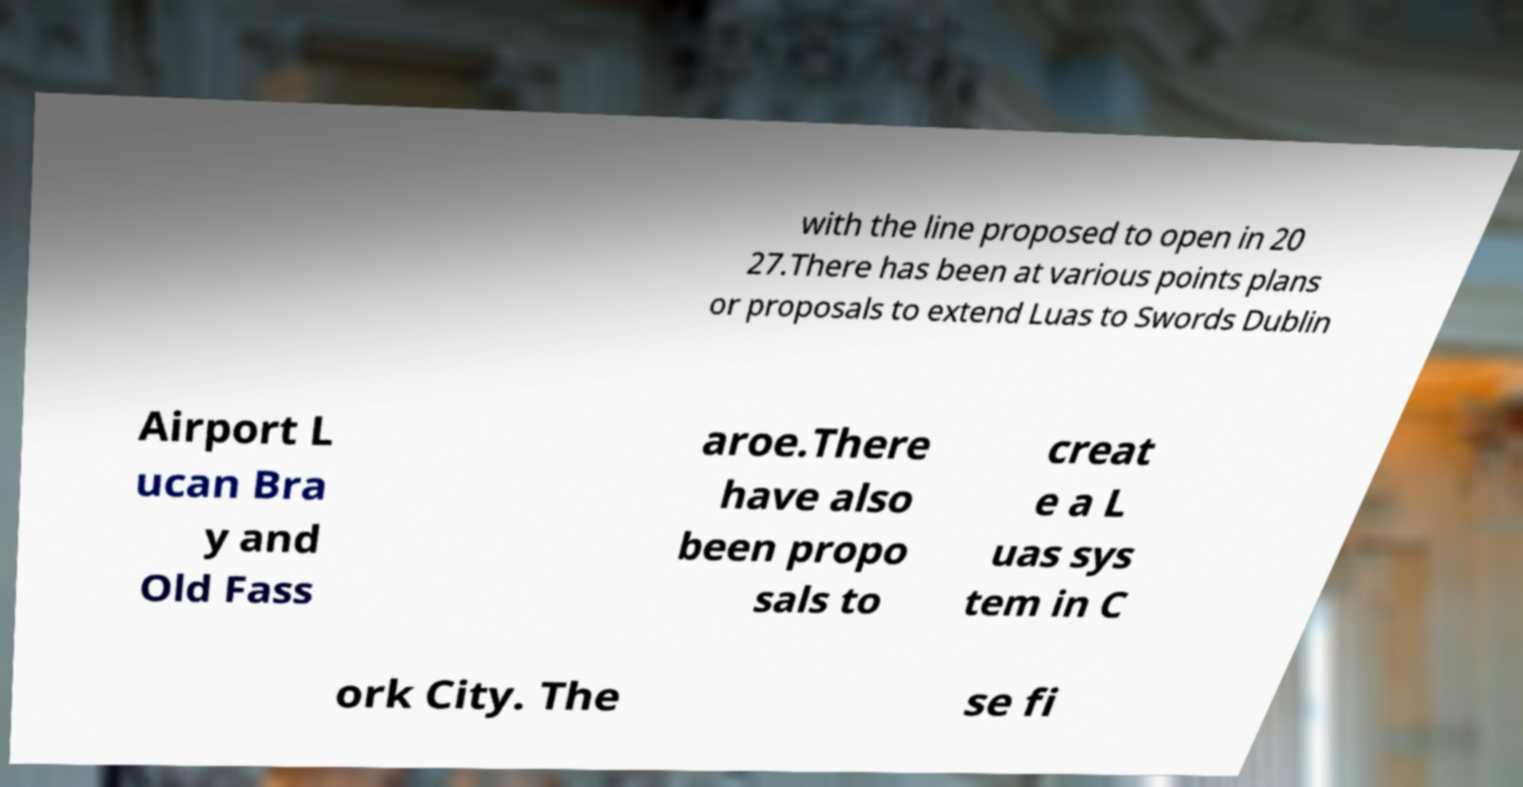I need the written content from this picture converted into text. Can you do that? with the line proposed to open in 20 27.There has been at various points plans or proposals to extend Luas to Swords Dublin Airport L ucan Bra y and Old Fass aroe.There have also been propo sals to creat e a L uas sys tem in C ork City. The se fi 